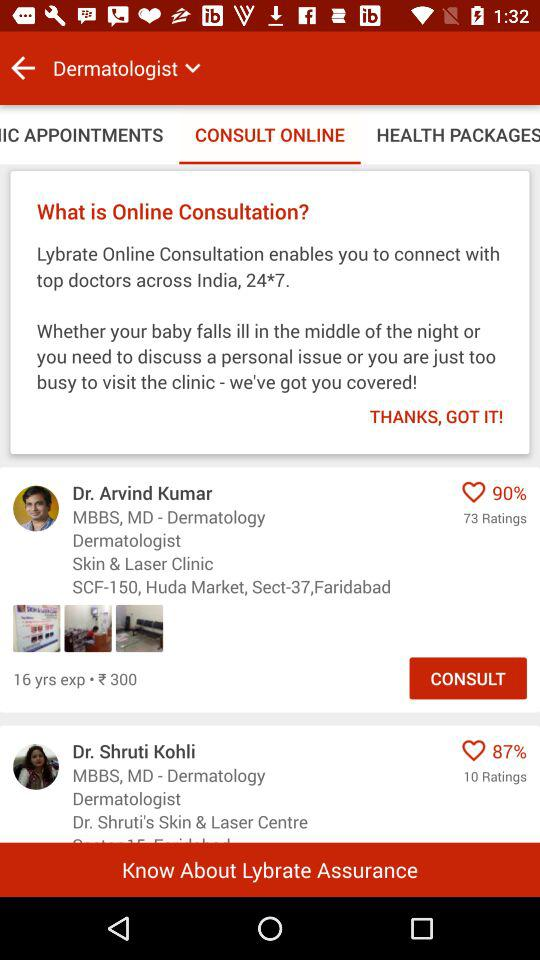Which option has been selected? The selected options are "Dermatologist" and "CONSULT ONLINE". 